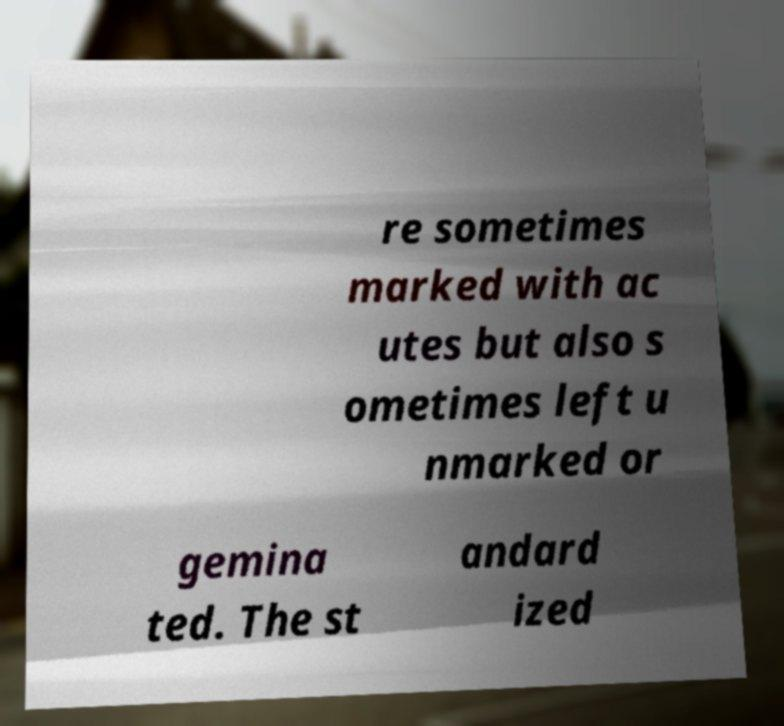Please identify and transcribe the text found in this image. re sometimes marked with ac utes but also s ometimes left u nmarked or gemina ted. The st andard ized 